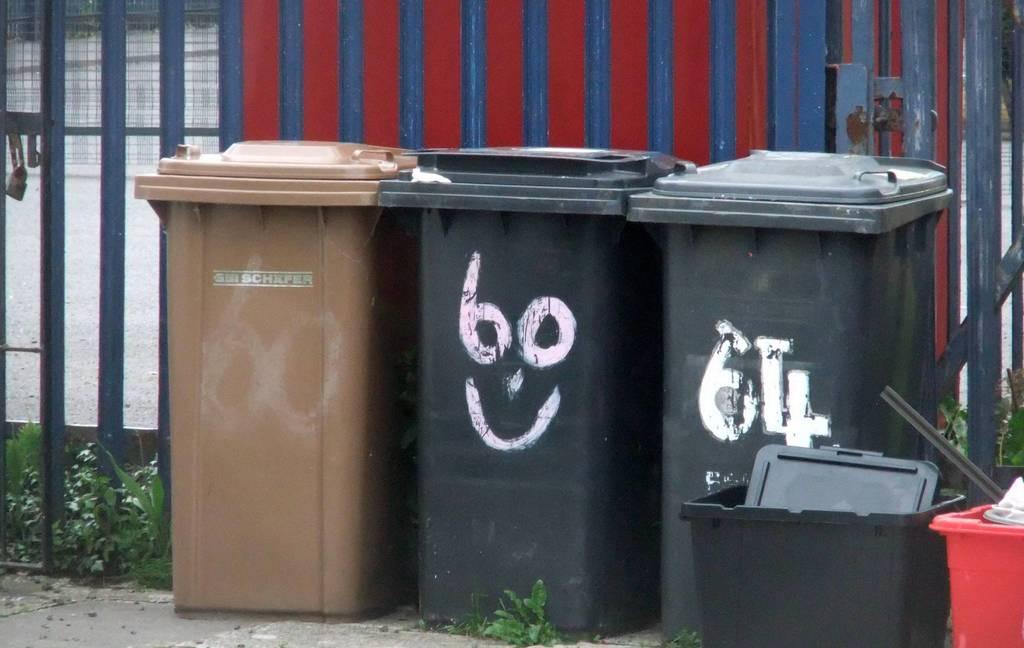What number is on the far right trashcan?
Give a very brief answer. 64. 